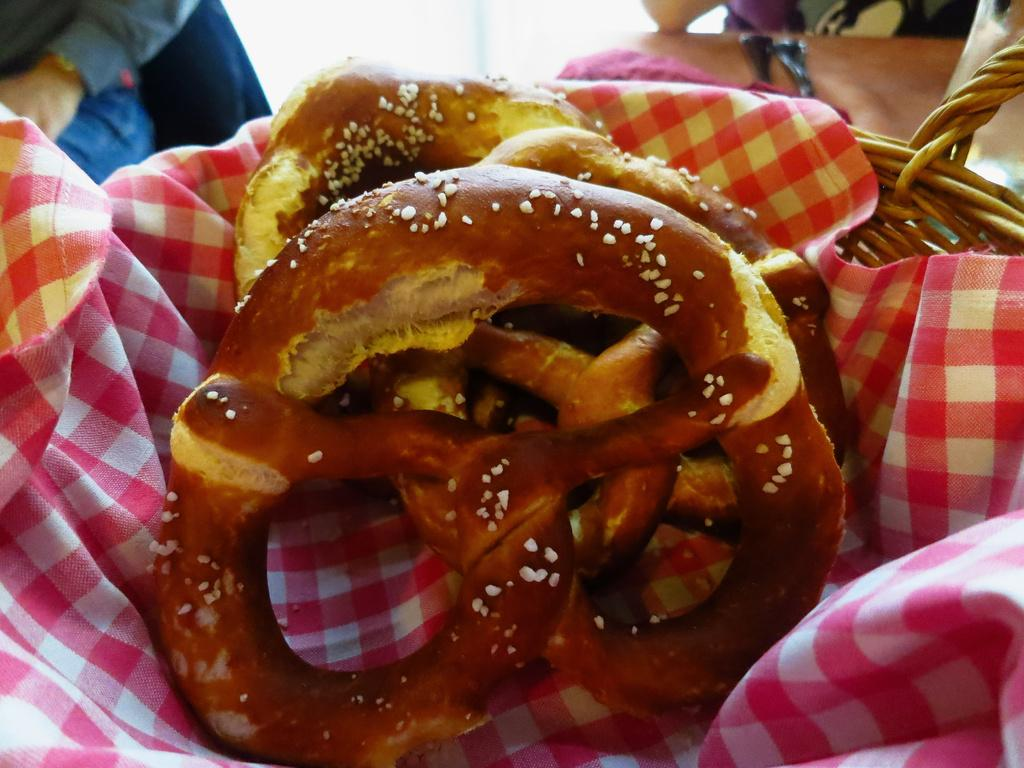What types of items can be seen in the image? There are food items and a basket containing cloth in the image. Can you describe the contents of the basket? The basket contains cloth. Are there any people visible in the image? Yes, there are two people in the background of the image. What type of fiction is the bee reading in the morning in the image? There is no bee or any reading material present in the image. 